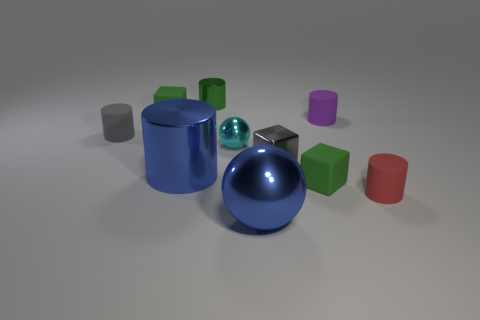Which is the largest object in this image and can you describe its color and texture? The largest object in the image is a cylindrical shape on the left. Its color is a vibrant blue, and it has a smooth, shiny metallic texture that reflects the environment around it. 